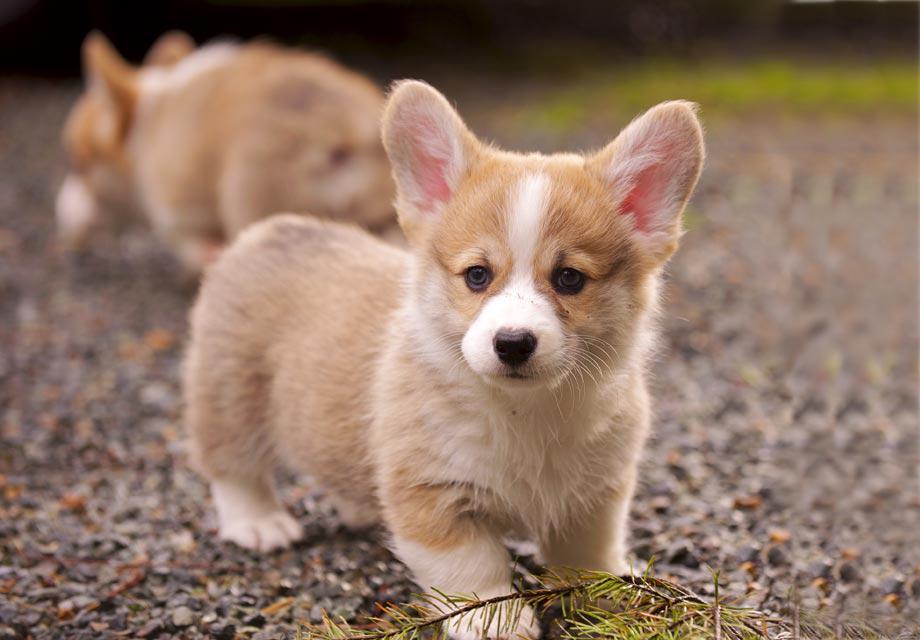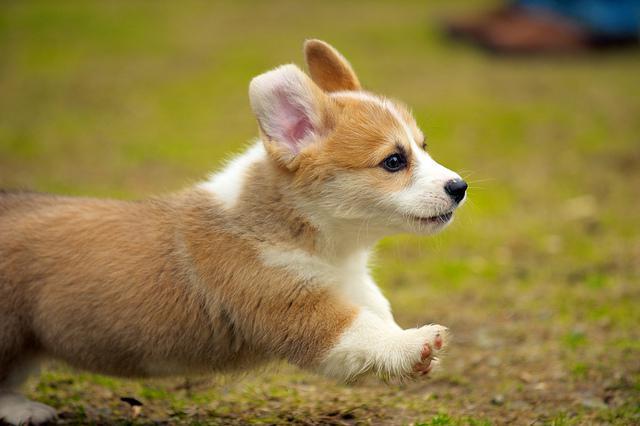The first image is the image on the left, the second image is the image on the right. Assess this claim about the two images: "An image shows a corgi dog bounding across the grass, with at least one front paw raised.". Correct or not? Answer yes or no. Yes. The first image is the image on the left, the second image is the image on the right. Analyze the images presented: Is the assertion "Two corgies have their ears pointed upward and their mouths open and smiling with tongues showing." valid? Answer yes or no. No. 